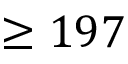Convert formula to latex. <formula><loc_0><loc_0><loc_500><loc_500>\geq 1 9 7</formula> 